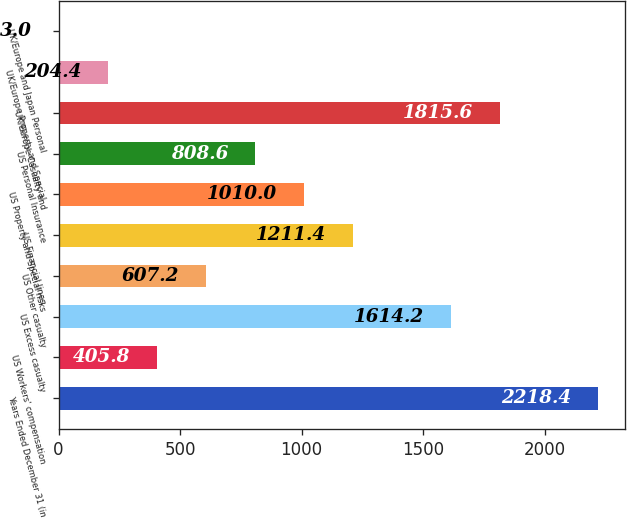<chart> <loc_0><loc_0><loc_500><loc_500><bar_chart><fcel>Years Ended December 31 (in<fcel>US Workers' compensation<fcel>US Excess casualty<fcel>US Other casualty<fcel>US Financial lines<fcel>US Property and Special risks<fcel>US Personal Insurance<fcel>UK/Europe Casualty and<fcel>UK/Europe Property and Special<fcel>UK/Europe and Japan Personal<nl><fcel>2218.4<fcel>405.8<fcel>1614.2<fcel>607.2<fcel>1211.4<fcel>1010<fcel>808.6<fcel>1815.6<fcel>204.4<fcel>3<nl></chart> 